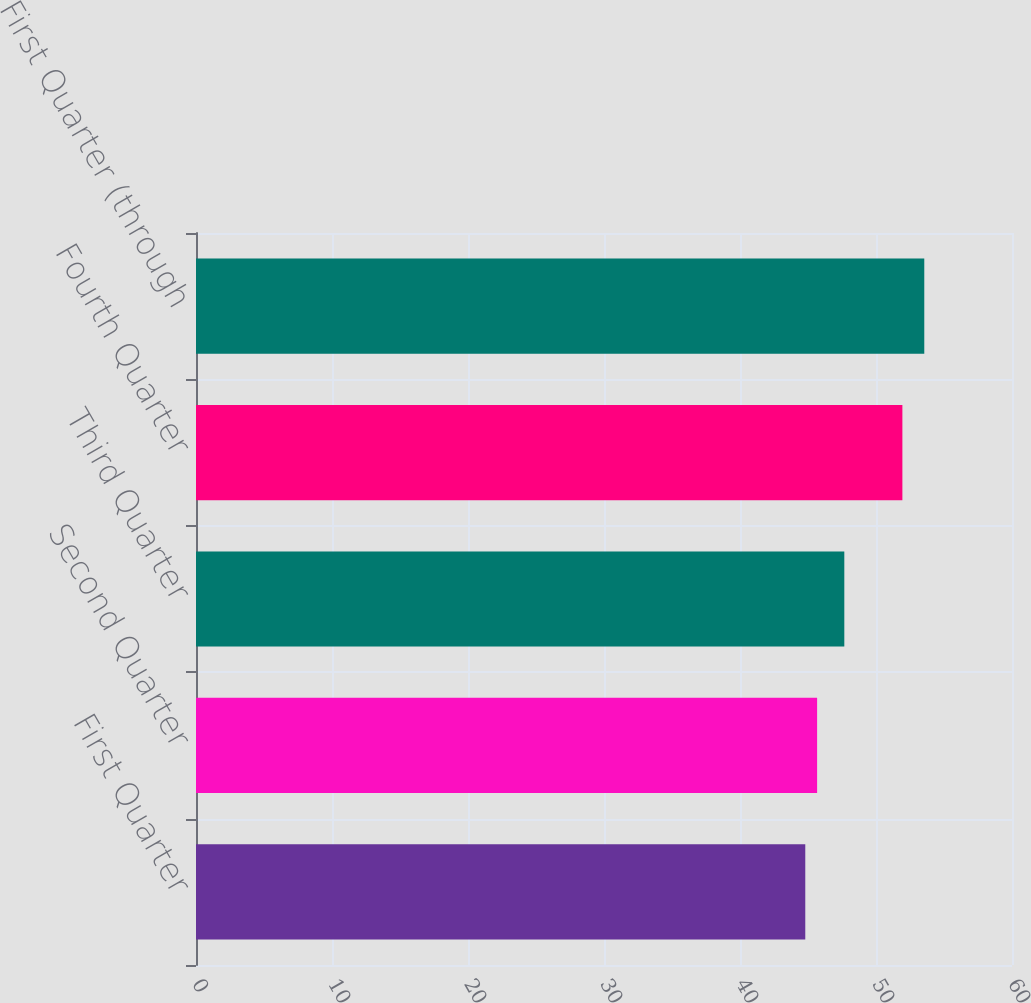Convert chart. <chart><loc_0><loc_0><loc_500><loc_500><bar_chart><fcel>First Quarter<fcel>Second Quarter<fcel>Third Quarter<fcel>Fourth Quarter<fcel>First Quarter (through<nl><fcel>44.8<fcel>45.67<fcel>47.67<fcel>51.94<fcel>53.55<nl></chart> 